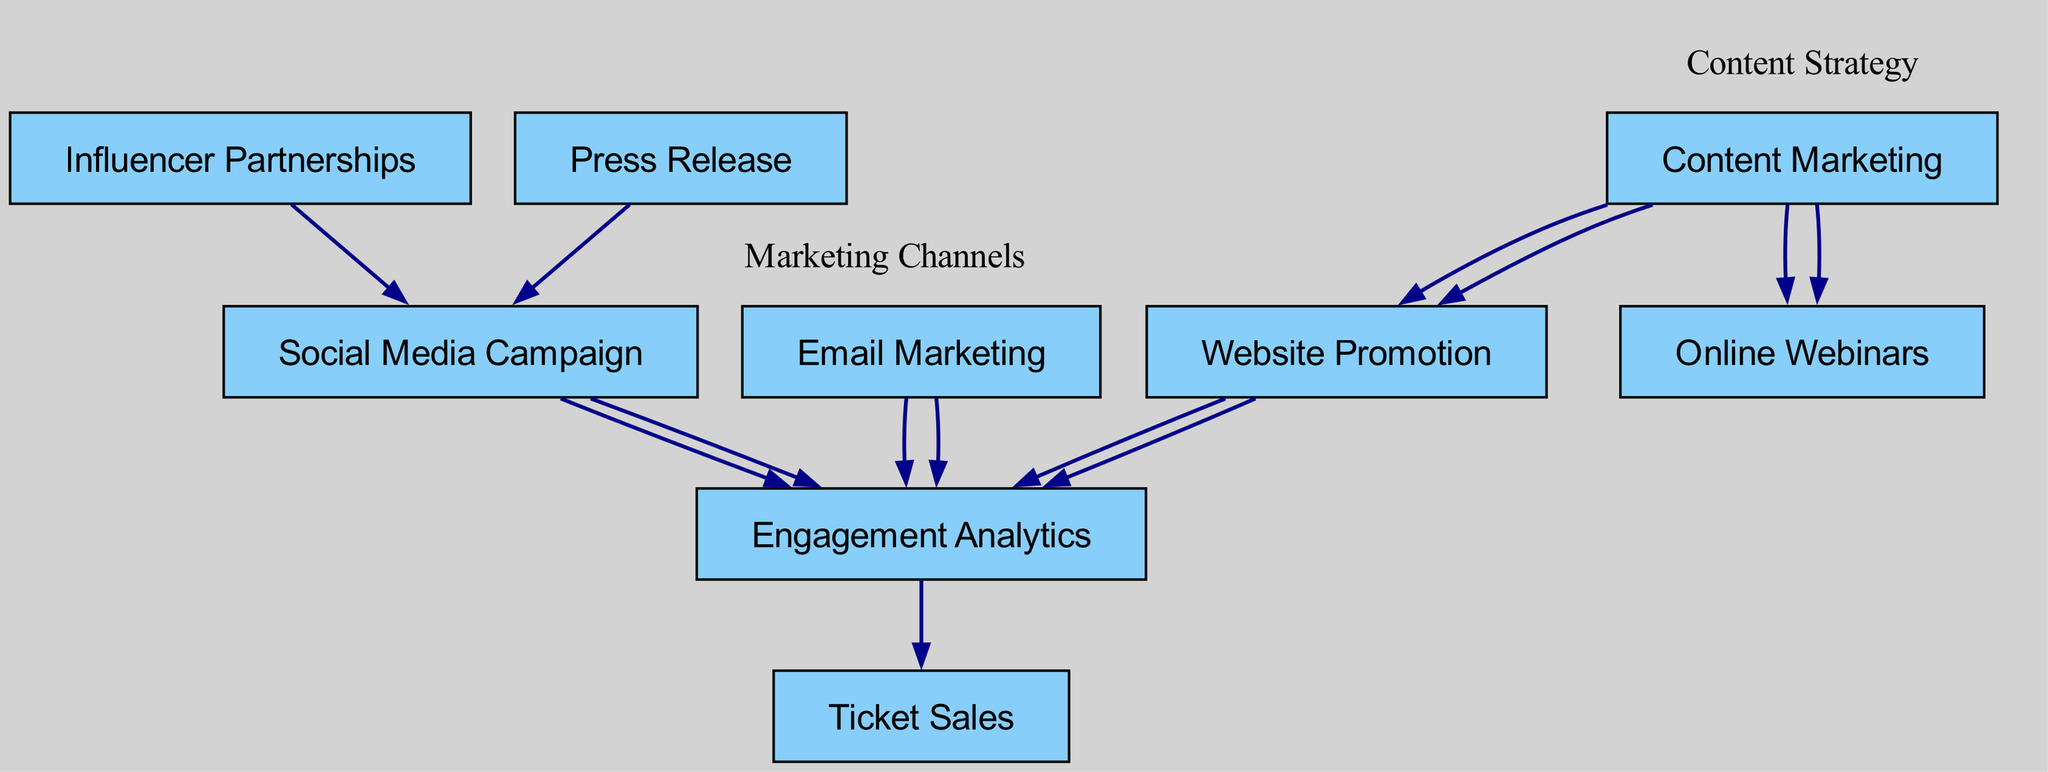What are the main marketing channels illustrated in the diagram? The diagram includes nodes for Social Media Campaign, Email Marketing, Website Promotion, Influencer Partnerships, Content Marketing, and Press Release, which represent the primary marketing channels used for promoting the conference.
Answer: Social Media Campaign, Email Marketing, Website Promotion, Influencer Partnerships, Content Marketing, Press Release How many nodes are present in the diagram? To determine the number of nodes, we count each unique marketing channel and strategy listed in the diagram's nodes section. There are a total of 9 unique nodes in the diagram.
Answer: 9 Which node has the most outgoing connections? By examining the edges from each node, Content Marketing has two outgoing connections: one to Website Promotion and another to Online Webinars, which is the most among all nodes.
Answer: Content Marketing What is the direction of influence from Influencer Partnerships? The Influencer Partnerships node directs its influence towards the Social Media Campaign node, indicating that partnerships enhance the social media efforts.
Answer: Social Media Campaign How do Engagement Analytics affect Ticket Sales? Engagement Analytics provides insights on attendee engagement metrics, which inform strategies leading to Ticket Sales; the edge from Engagement Analytics to Ticket Sales indicates a direct influence or flow of information leading to ticket purchases.
Answer: Ticket Sales How many edges are present in the diagram? An edge represents a connection from one node to another. By counting the listed connections in the edges section of the diagram, we find there are a total of 8 edges.
Answer: 8 Which marketing channels lead to Engagement Analytics? The channels that lead to Engagement Analytics based on the edges are Social Media Campaign, Email Marketing, and Website Promotion. These connections signify that engagement metrics are influenced by these channels.
Answer: Social Media Campaign, Email Marketing, Website Promotion What is the role of Content Marketing in this strategy flow? Content Marketing acts as a facilitator in the flow; it connects to both Website Promotion and Online Webinars, indicating its importance in driving interest through valuable content that supports promotional activities.
Answer: Website Promotion, Online Webinars What is the relationship between Press Release and Social Media Campaign? The relationship is directional; Press Release influences the Social Media Campaign, suggesting that the distribution of press releases enhances visibility and engagement through social media platforms.
Answer: Social Media Campaign 